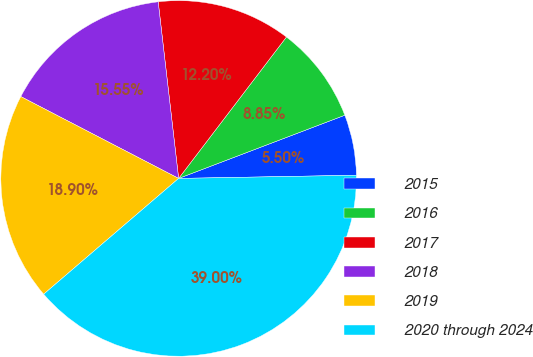Convert chart. <chart><loc_0><loc_0><loc_500><loc_500><pie_chart><fcel>2015<fcel>2016<fcel>2017<fcel>2018<fcel>2019<fcel>2020 through 2024<nl><fcel>5.5%<fcel>8.85%<fcel>12.2%<fcel>15.55%<fcel>18.9%<fcel>39.0%<nl></chart> 